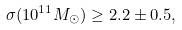<formula> <loc_0><loc_0><loc_500><loc_500>\sigma ( 1 0 ^ { 1 1 } M _ { \odot } ) \geq 2 . 2 \pm 0 . 5 ,</formula> 